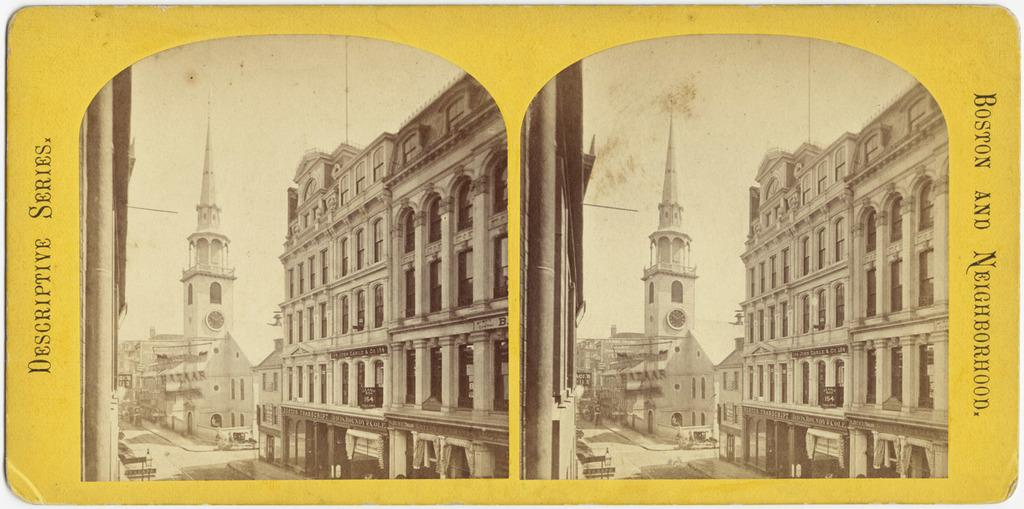What is the main subject of the image? The main subject of the image is a poster. What can be seen on the poster? There are two collage images on the poster, along with buildings, a tower, a road, and text on both the right and left sides. What type of treatment is being offered for the winter season in the image? There is no mention of treatment or winter in the image; it features a poster with collage images and text. 